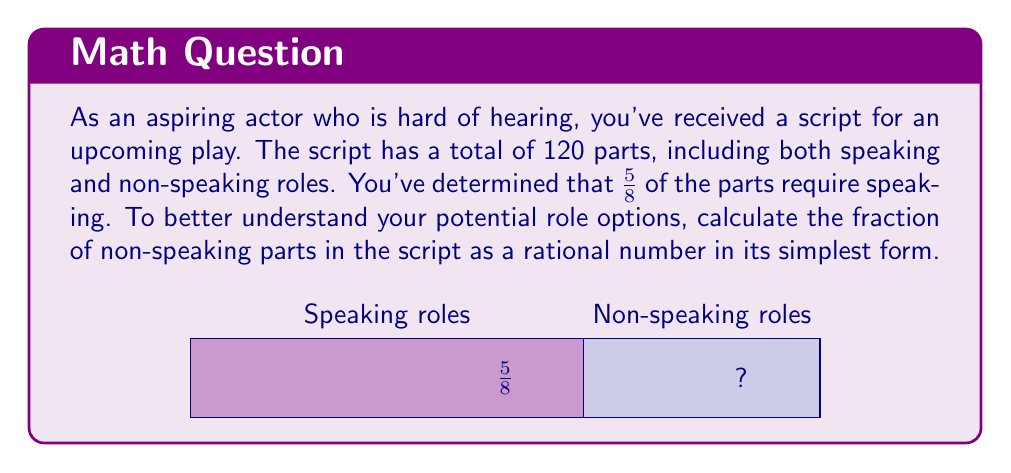Can you solve this math problem? Let's approach this step-by-step:

1) We know that the total number of parts is 120, and $\frac{5}{8}$ of these are speaking parts.

2) To find the fraction of non-speaking parts, we need to subtract the fraction of speaking parts from 1 (the whole):

   $1 - \frac{5}{8} = \frac{8}{8} - \frac{5}{8} = \frac{3}{8}$

3) Now we have our fraction of non-speaking parts: $\frac{3}{8}$

4) To verify if this is in its simplest form, we need to check if there's a common factor between the numerator and denominator:
   
   The factors of 3 are: 1 and 3
   The factors of 8 are: 1, 2, 4, and 8

   The greatest common factor is 1, so $\frac{3}{8}$ is already in its simplest form.

Therefore, the fraction of non-speaking parts in the script is $\frac{3}{8}$.
Answer: $\frac{3}{8}$ 